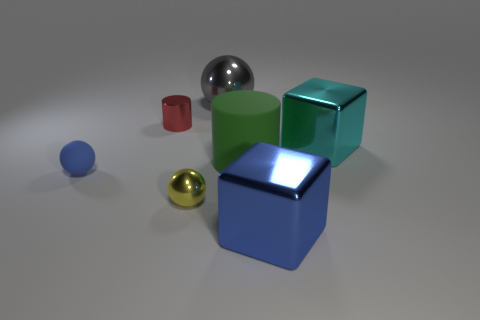Add 2 gray blocks. How many objects exist? 9 Subtract all cubes. How many objects are left? 5 Subtract all metallic balls. Subtract all small brown rubber spheres. How many objects are left? 5 Add 2 small metal objects. How many small metal objects are left? 4 Add 5 tiny red metallic cylinders. How many tiny red metallic cylinders exist? 6 Subtract 0 blue cylinders. How many objects are left? 7 